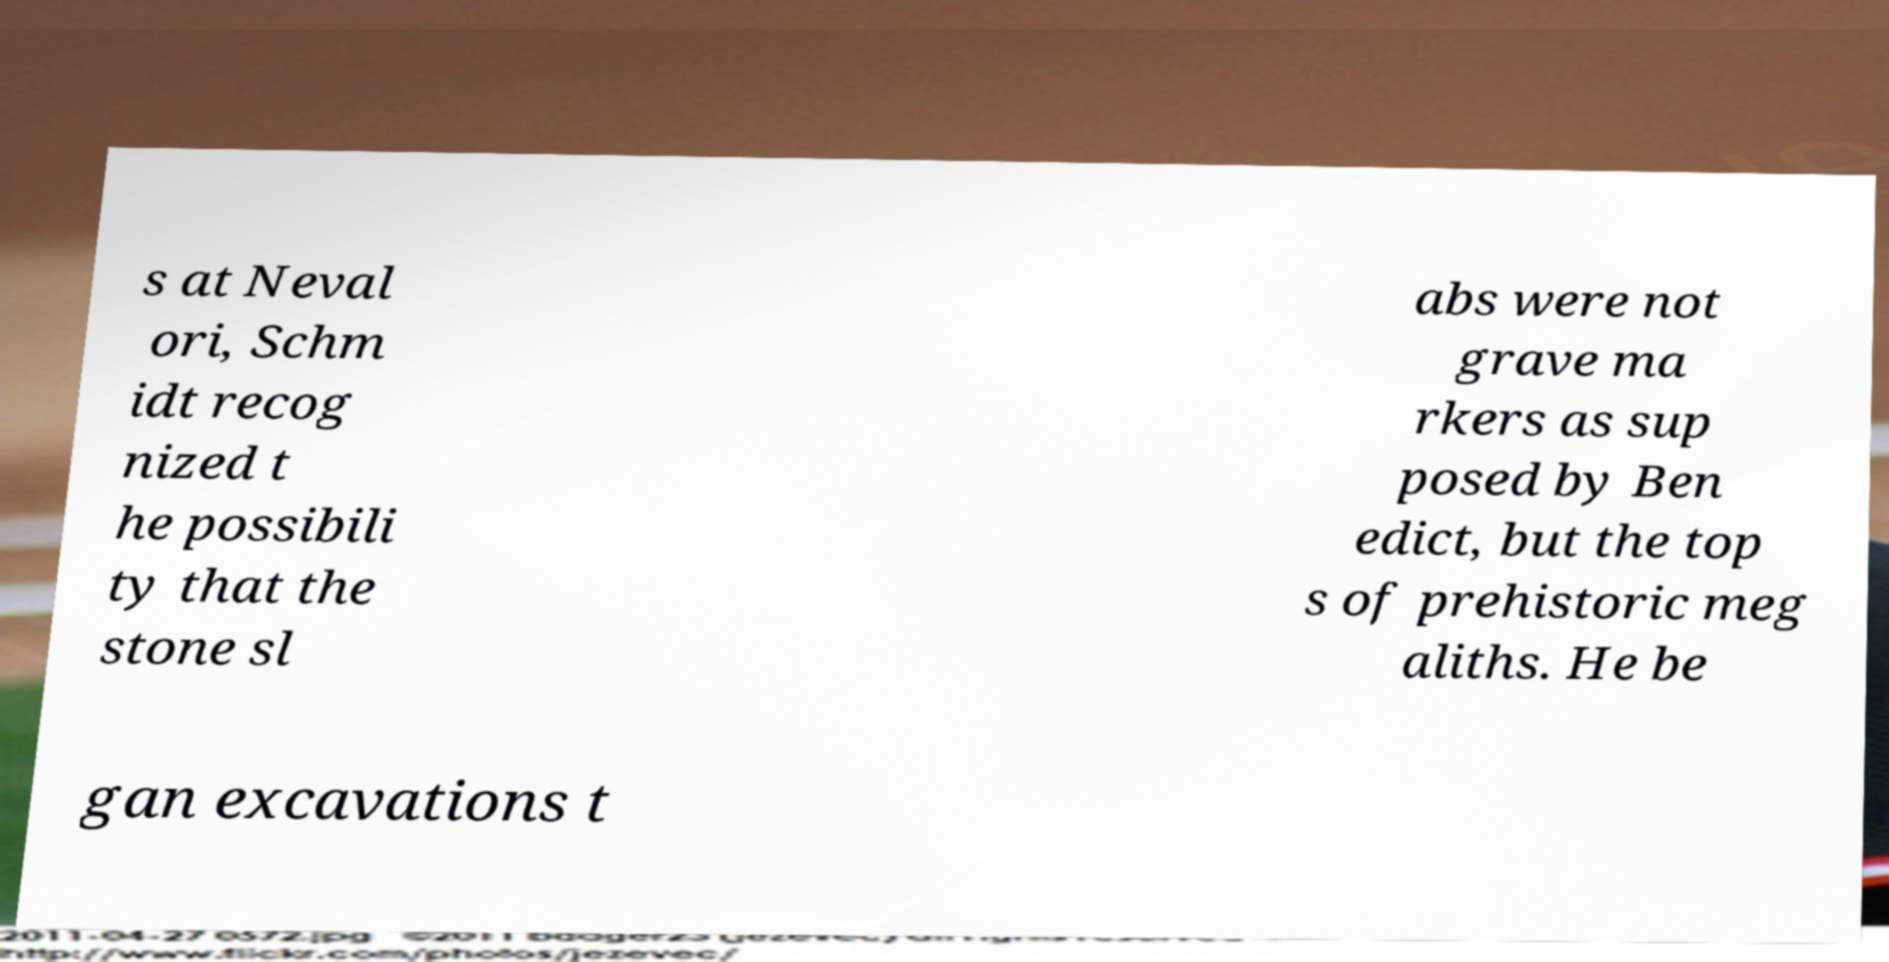Could you extract and type out the text from this image? s at Neval ori, Schm idt recog nized t he possibili ty that the stone sl abs were not grave ma rkers as sup posed by Ben edict, but the top s of prehistoric meg aliths. He be gan excavations t 